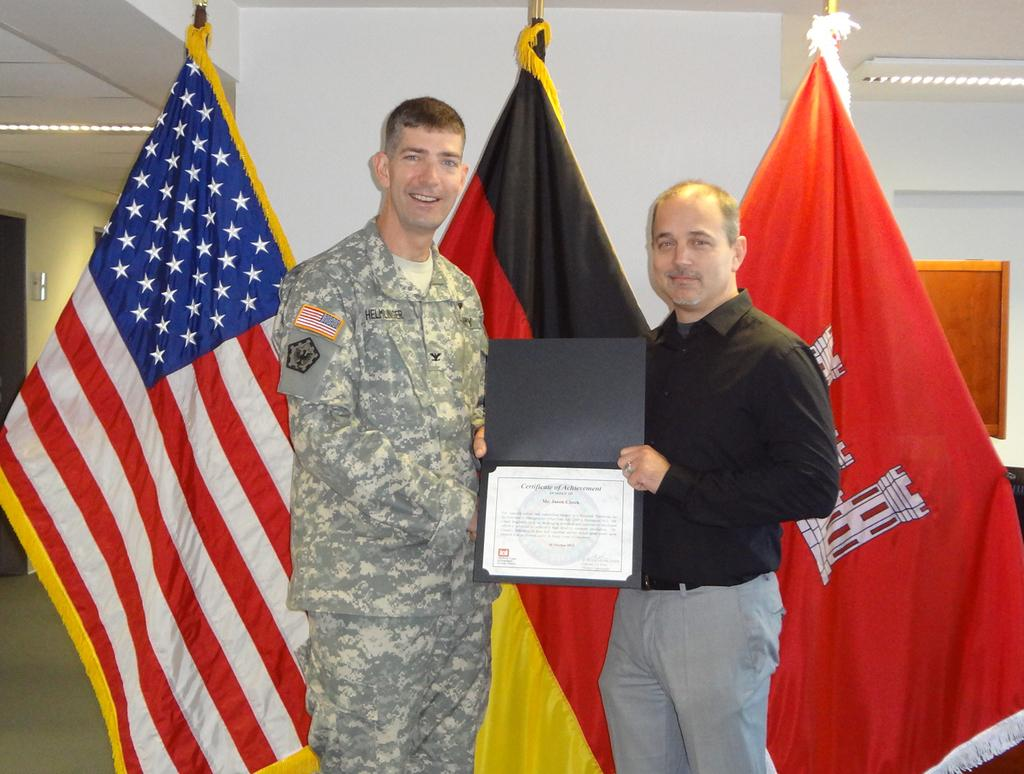Provide a one-sentence caption for the provided image. A man received a certificate of achievement and poses with flags behind him. 